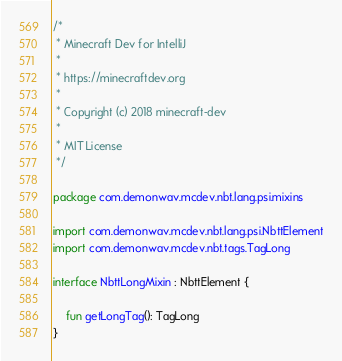Convert code to text. <code><loc_0><loc_0><loc_500><loc_500><_Kotlin_>/*
 * Minecraft Dev for IntelliJ
 *
 * https://minecraftdev.org
 *
 * Copyright (c) 2018 minecraft-dev
 *
 * MIT License
 */

package com.demonwav.mcdev.nbt.lang.psi.mixins

import com.demonwav.mcdev.nbt.lang.psi.NbttElement
import com.demonwav.mcdev.nbt.tags.TagLong

interface NbttLongMixin : NbttElement {

    fun getLongTag(): TagLong
}
</code> 